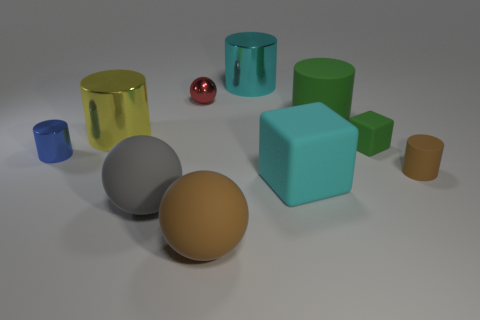Subtract all brown cylinders. How many cylinders are left? 4 Subtract all green matte cylinders. How many cylinders are left? 4 Subtract all gray cylinders. Subtract all brown balls. How many cylinders are left? 5 Subtract all blocks. How many objects are left? 8 Add 9 brown cylinders. How many brown cylinders are left? 10 Add 4 big cyan metallic objects. How many big cyan metallic objects exist? 5 Subtract 1 red spheres. How many objects are left? 9 Subtract all large matte cylinders. Subtract all small red metal balls. How many objects are left? 8 